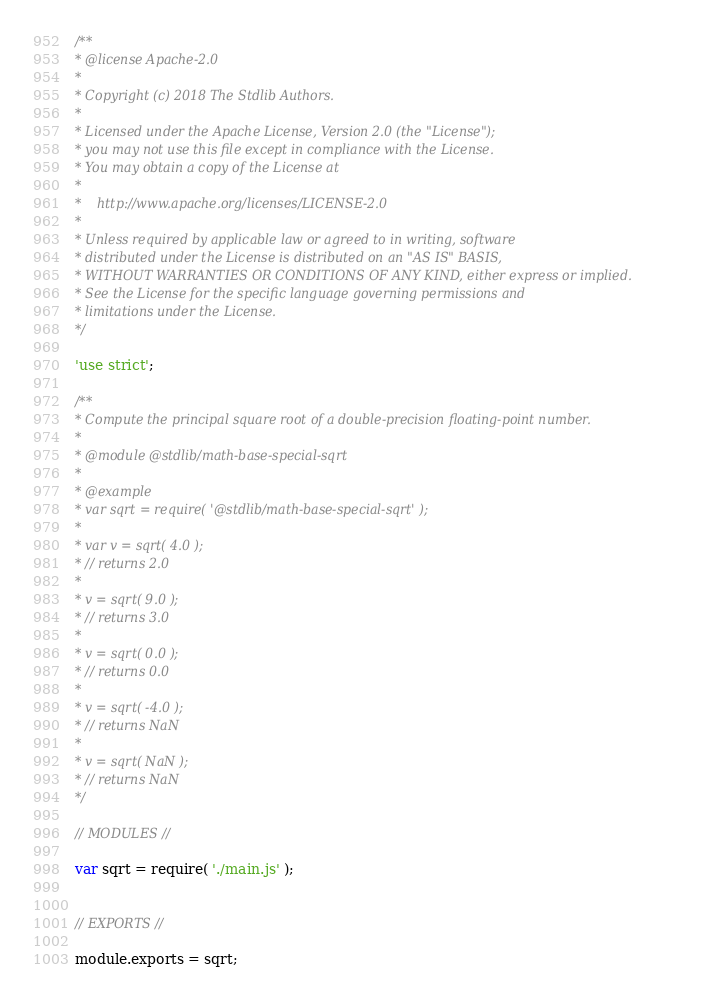<code> <loc_0><loc_0><loc_500><loc_500><_JavaScript_>/**
* @license Apache-2.0
*
* Copyright (c) 2018 The Stdlib Authors.
*
* Licensed under the Apache License, Version 2.0 (the "License");
* you may not use this file except in compliance with the License.
* You may obtain a copy of the License at
*
*    http://www.apache.org/licenses/LICENSE-2.0
*
* Unless required by applicable law or agreed to in writing, software
* distributed under the License is distributed on an "AS IS" BASIS,
* WITHOUT WARRANTIES OR CONDITIONS OF ANY KIND, either express or implied.
* See the License for the specific language governing permissions and
* limitations under the License.
*/

'use strict';

/**
* Compute the principal square root of a double-precision floating-point number.
*
* @module @stdlib/math-base-special-sqrt
*
* @example
* var sqrt = require( '@stdlib/math-base-special-sqrt' );
*
* var v = sqrt( 4.0 );
* // returns 2.0
*
* v = sqrt( 9.0 );
* // returns 3.0
*
* v = sqrt( 0.0 );
* // returns 0.0
*
* v = sqrt( -4.0 );
* // returns NaN
*
* v = sqrt( NaN );
* // returns NaN
*/

// MODULES //

var sqrt = require( './main.js' );


// EXPORTS //

module.exports = sqrt;
</code> 